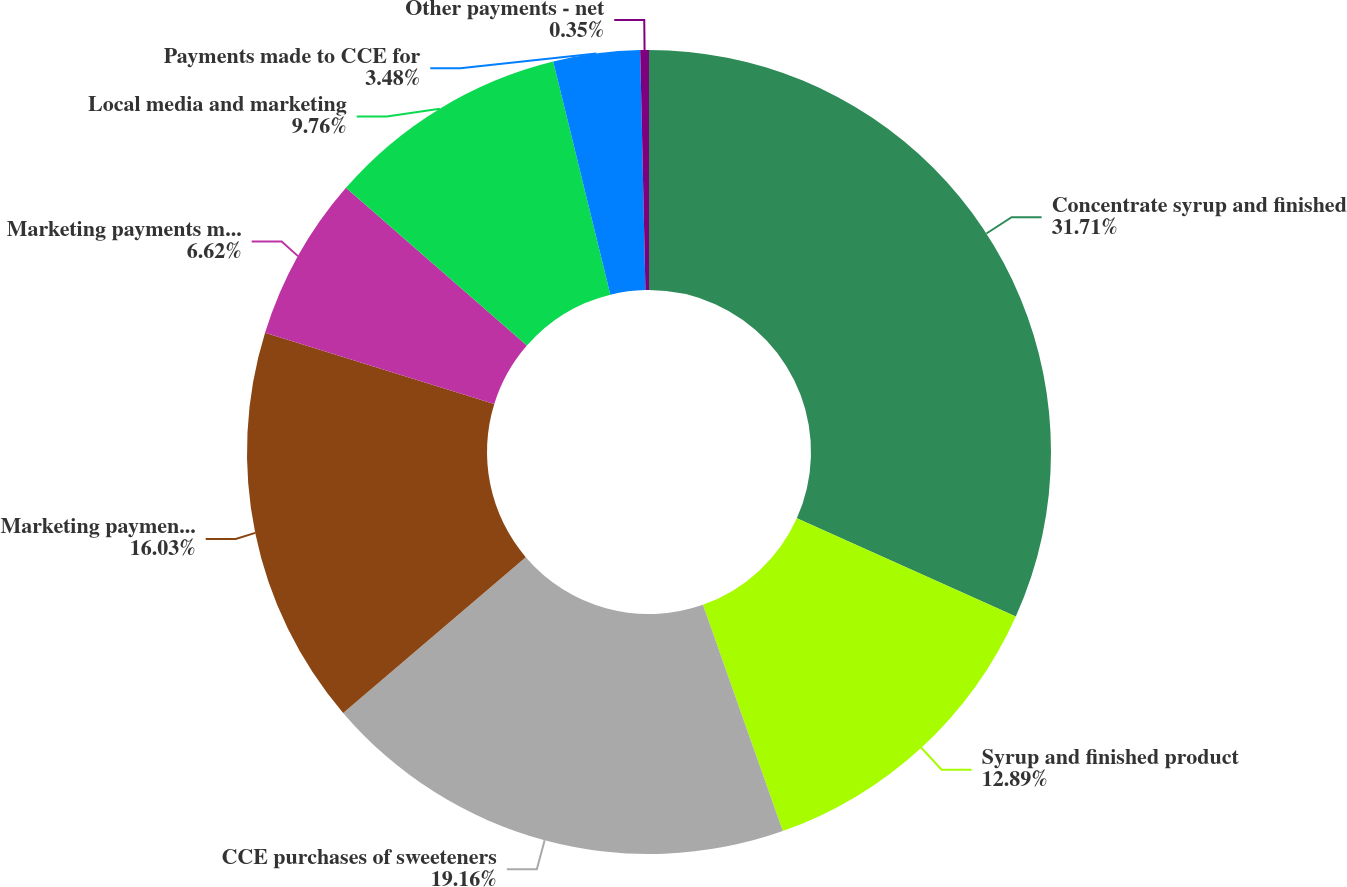<chart> <loc_0><loc_0><loc_500><loc_500><pie_chart><fcel>Concentrate syrup and finished<fcel>Syrup and finished product<fcel>CCE purchases of sweeteners<fcel>Marketing payments made by us<fcel>Marketing payments made to<fcel>Local media and marketing<fcel>Payments made to CCE for<fcel>Other payments - net<nl><fcel>31.71%<fcel>12.89%<fcel>19.16%<fcel>16.03%<fcel>6.62%<fcel>9.76%<fcel>3.48%<fcel>0.35%<nl></chart> 